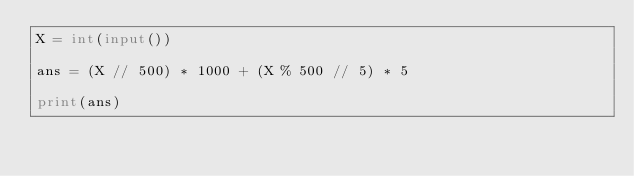Convert code to text. <code><loc_0><loc_0><loc_500><loc_500><_Python_>X = int(input())

ans = (X // 500) * 1000 + (X % 500 // 5) * 5

print(ans)
</code> 